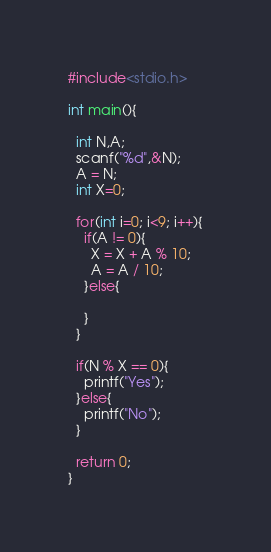<code> <loc_0><loc_0><loc_500><loc_500><_C_>#include<stdio.h>

int main(){
  
  int N,A;
  scanf("%d",&N);
  A = N;
  int X=0;

  for(int i=0; i<9; i++){
    if(A != 0){
      X = X + A % 10;
      A = A / 10;
    }else{

    }
  }

  if(N % X == 0){
    printf("Yes");
  }else{
    printf("No");
  }

  return 0;
}</code> 